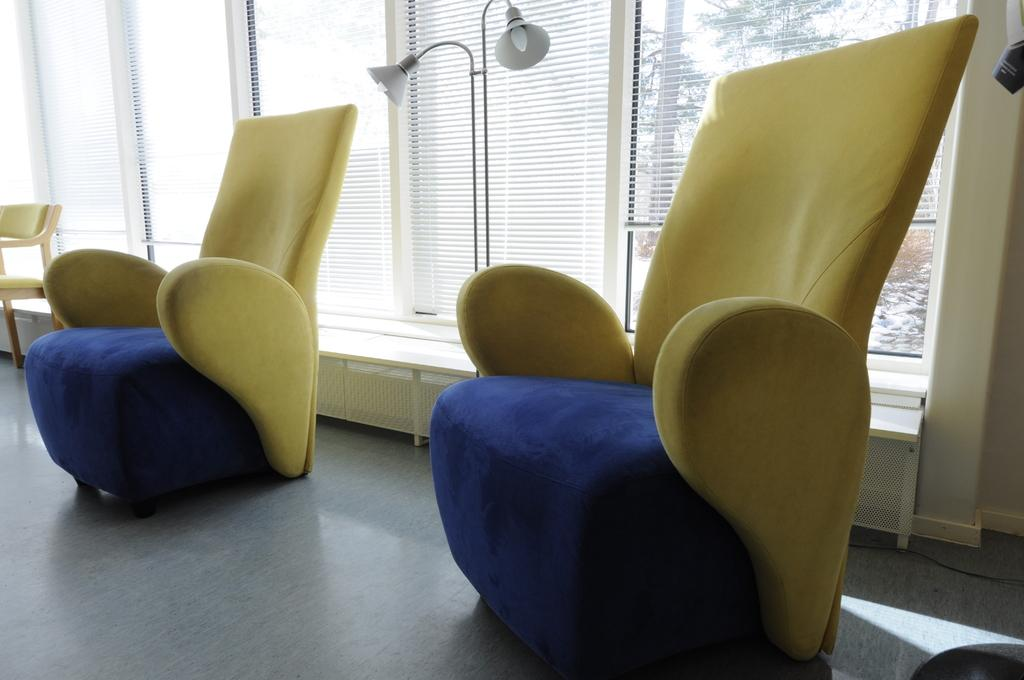What type of furniture is present in the image? There are chairs in the image. What type of lighting is present in the image? There are lamps in the image. What allows natural light to enter the room in the image? There are windows in the image. What can be seen through the windows in the image? Trees are visible behind the windows. What type of headwear is worn by the trees visible through the windows? There are no people or headwear present in the image; it features chairs, lamps, windows, and trees. 